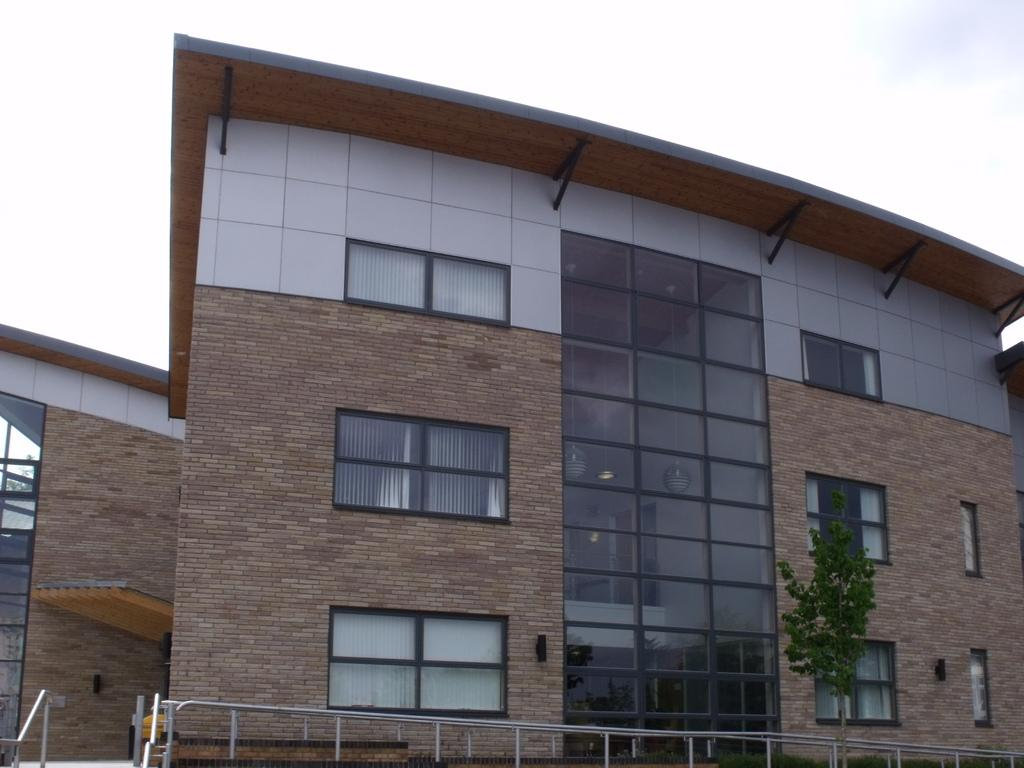What type of structure is in the picture? There is a building in the picture. What feature can be seen on the building? The building has glass windows. What is located on the right side of the building? There is a plant on the right side of the building. What can be seen near the building? There is a railing in the picture. How would you describe the sky in the picture? The sky is clear in the picture. How many brothers are visible in the picture? There are no brothers present in the image; it features a building with a plant and a railing. What color are the eyes of the plant in the picture? Plants do not have eyes, so this question cannot be answered. 